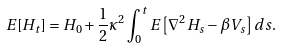<formula> <loc_0><loc_0><loc_500><loc_500>E [ H _ { t } ] = H _ { 0 } + \frac { 1 } { 2 } \kappa ^ { 2 } \int _ { 0 } ^ { t } E \left [ \nabla ^ { 2 } H _ { s } - \beta V _ { s } \right ] d s .</formula> 